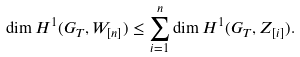<formula> <loc_0><loc_0><loc_500><loc_500>\dim H ^ { 1 } ( G _ { T } , W _ { [ n ] } ) \leq \sum _ { i = 1 } ^ { n } \dim H ^ { 1 } ( G _ { T } , Z _ { [ i ] } ) .</formula> 